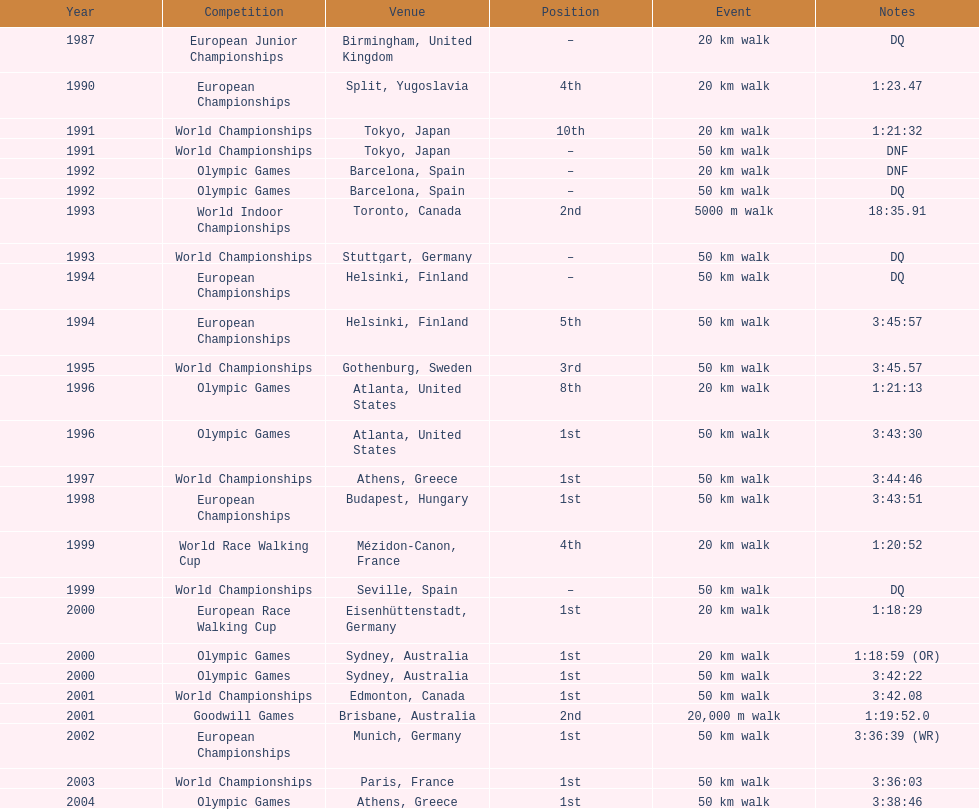Can you parse all the data within this table? {'header': ['Year', 'Competition', 'Venue', 'Position', 'Event', 'Notes'], 'rows': [['1987', 'European Junior Championships', 'Birmingham, United Kingdom', '–', '20\xa0km walk', 'DQ'], ['1990', 'European Championships', 'Split, Yugoslavia', '4th', '20\xa0km walk', '1:23.47'], ['1991', 'World Championships', 'Tokyo, Japan', '10th', '20\xa0km walk', '1:21:32'], ['1991', 'World Championships', 'Tokyo, Japan', '–', '50\xa0km walk', 'DNF'], ['1992', 'Olympic Games', 'Barcelona, Spain', '–', '20\xa0km walk', 'DNF'], ['1992', 'Olympic Games', 'Barcelona, Spain', '–', '50\xa0km walk', 'DQ'], ['1993', 'World Indoor Championships', 'Toronto, Canada', '2nd', '5000 m walk', '18:35.91'], ['1993', 'World Championships', 'Stuttgart, Germany', '–', '50\xa0km walk', 'DQ'], ['1994', 'European Championships', 'Helsinki, Finland', '–', '50\xa0km walk', 'DQ'], ['1994', 'European Championships', 'Helsinki, Finland', '5th', '50\xa0km walk', '3:45:57'], ['1995', 'World Championships', 'Gothenburg, Sweden', '3rd', '50\xa0km walk', '3:45.57'], ['1996', 'Olympic Games', 'Atlanta, United States', '8th', '20\xa0km walk', '1:21:13'], ['1996', 'Olympic Games', 'Atlanta, United States', '1st', '50\xa0km walk', '3:43:30'], ['1997', 'World Championships', 'Athens, Greece', '1st', '50\xa0km walk', '3:44:46'], ['1998', 'European Championships', 'Budapest, Hungary', '1st', '50\xa0km walk', '3:43:51'], ['1999', 'World Race Walking Cup', 'Mézidon-Canon, France', '4th', '20\xa0km walk', '1:20:52'], ['1999', 'World Championships', 'Seville, Spain', '–', '50\xa0km walk', 'DQ'], ['2000', 'European Race Walking Cup', 'Eisenhüttenstadt, Germany', '1st', '20\xa0km walk', '1:18:29'], ['2000', 'Olympic Games', 'Sydney, Australia', '1st', '20\xa0km walk', '1:18:59 (OR)'], ['2000', 'Olympic Games', 'Sydney, Australia', '1st', '50\xa0km walk', '3:42:22'], ['2001', 'World Championships', 'Edmonton, Canada', '1st', '50\xa0km walk', '3:42.08'], ['2001', 'Goodwill Games', 'Brisbane, Australia', '2nd', '20,000 m walk', '1:19:52.0'], ['2002', 'European Championships', 'Munich, Germany', '1st', '50\xa0km walk', '3:36:39 (WR)'], ['2003', 'World Championships', 'Paris, France', '1st', '50\xa0km walk', '3:36:03'], ['2004', 'Olympic Games', 'Athens, Greece', '1st', '50\xa0km walk', '3:38:46']]} In the 2004 olympics, how much time was required to complete the 50 km walk? 3:38:46. 